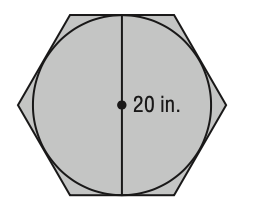Answer the mathemtical geometry problem and directly provide the correct option letter.
Question: What is the area of the figure? Round to the nearest tenth.
Choices: A: 346.4 B: 372.1 C: 383.2 D: 564.7 A 